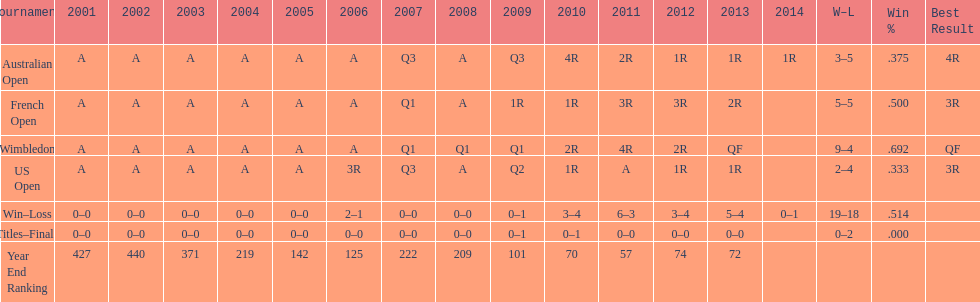What was this players average ranking between 2001 and 2006? 287. 